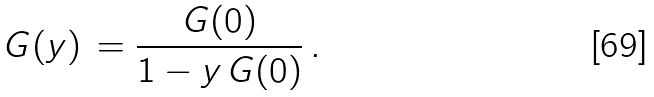<formula> <loc_0><loc_0><loc_500><loc_500>G ( y ) \, = \frac { G ( 0 ) } { 1 - y \, G ( 0 ) } \, .</formula> 